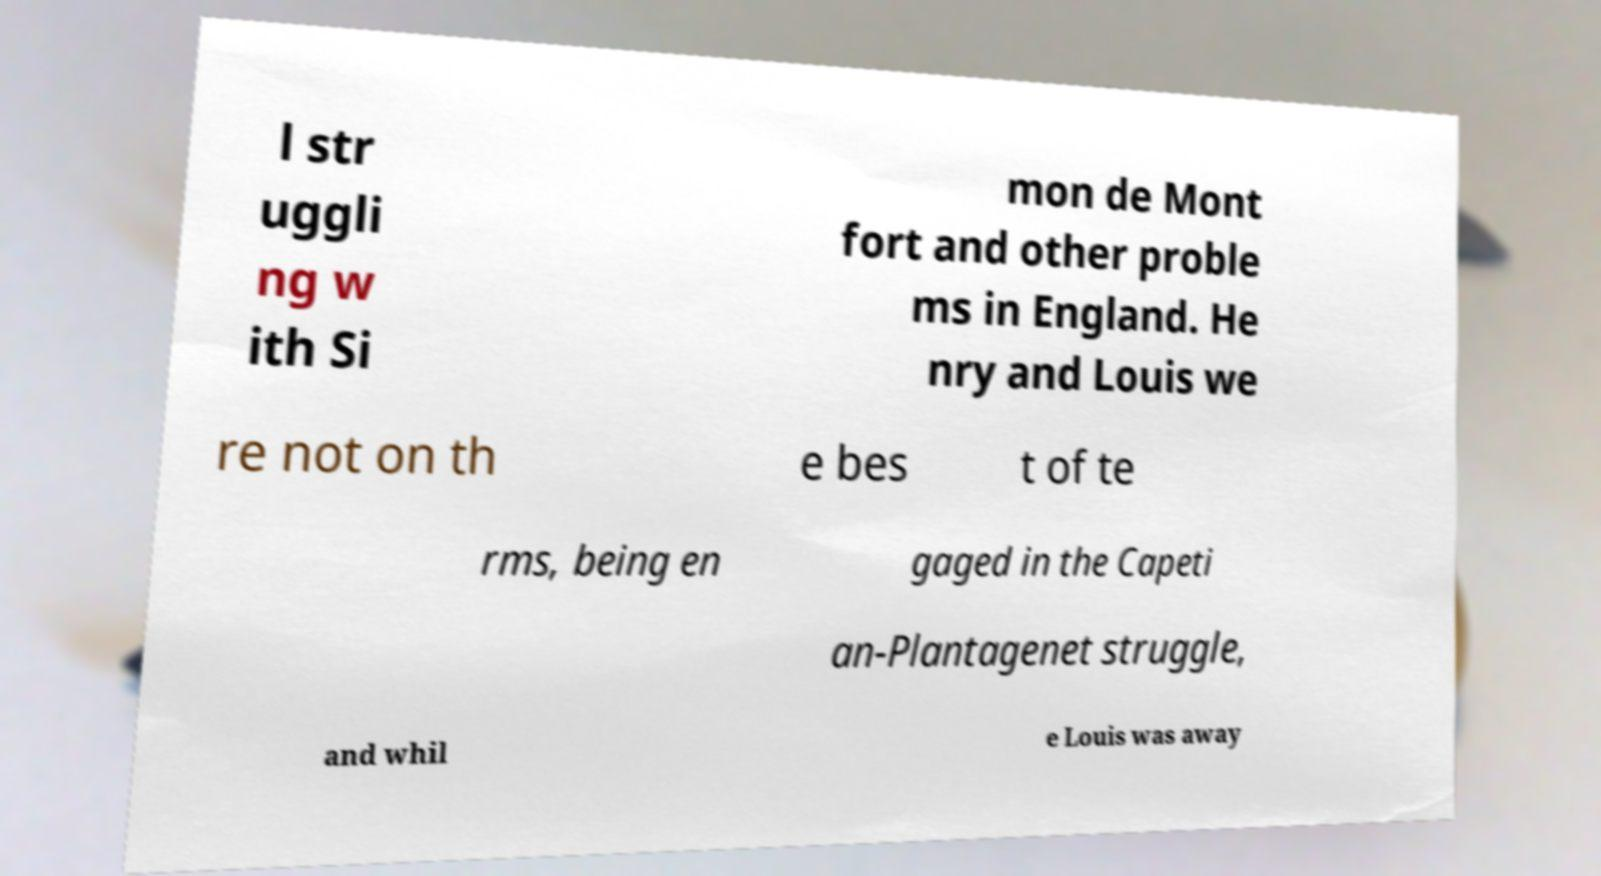What messages or text are displayed in this image? I need them in a readable, typed format. l str uggli ng w ith Si mon de Mont fort and other proble ms in England. He nry and Louis we re not on th e bes t of te rms, being en gaged in the Capeti an-Plantagenet struggle, and whil e Louis was away 